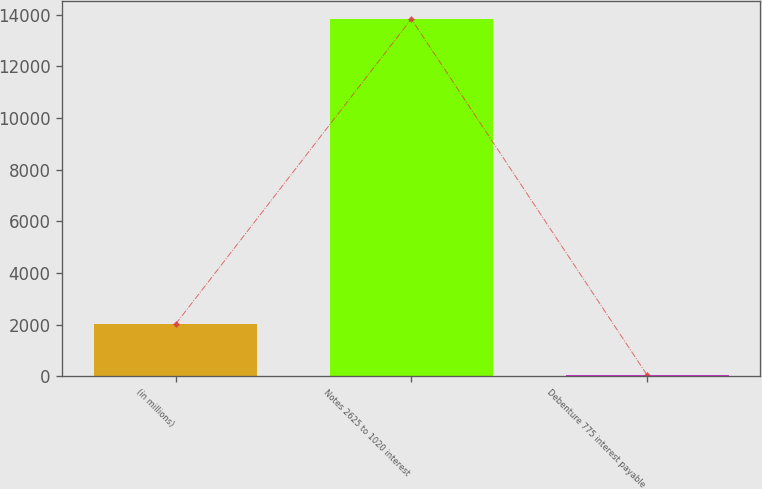Convert chart to OTSL. <chart><loc_0><loc_0><loc_500><loc_500><bar_chart><fcel>(in millions)<fcel>Notes 2625 to 1020 interest<fcel>Debenture 775 interest payable<nl><fcel>2016<fcel>13839<fcel>42<nl></chart> 